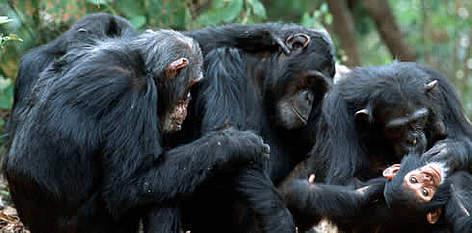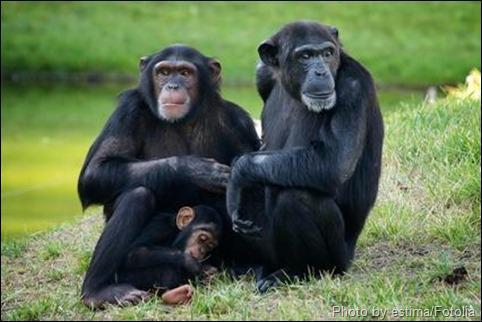The first image is the image on the left, the second image is the image on the right. Assess this claim about the two images: "The image on the right shows a single animal gazing into the distance.". Correct or not? Answer yes or no. No. The first image is the image on the left, the second image is the image on the right. Analyze the images presented: Is the assertion "The left photo contains a single chimp." valid? Answer yes or no. No. 